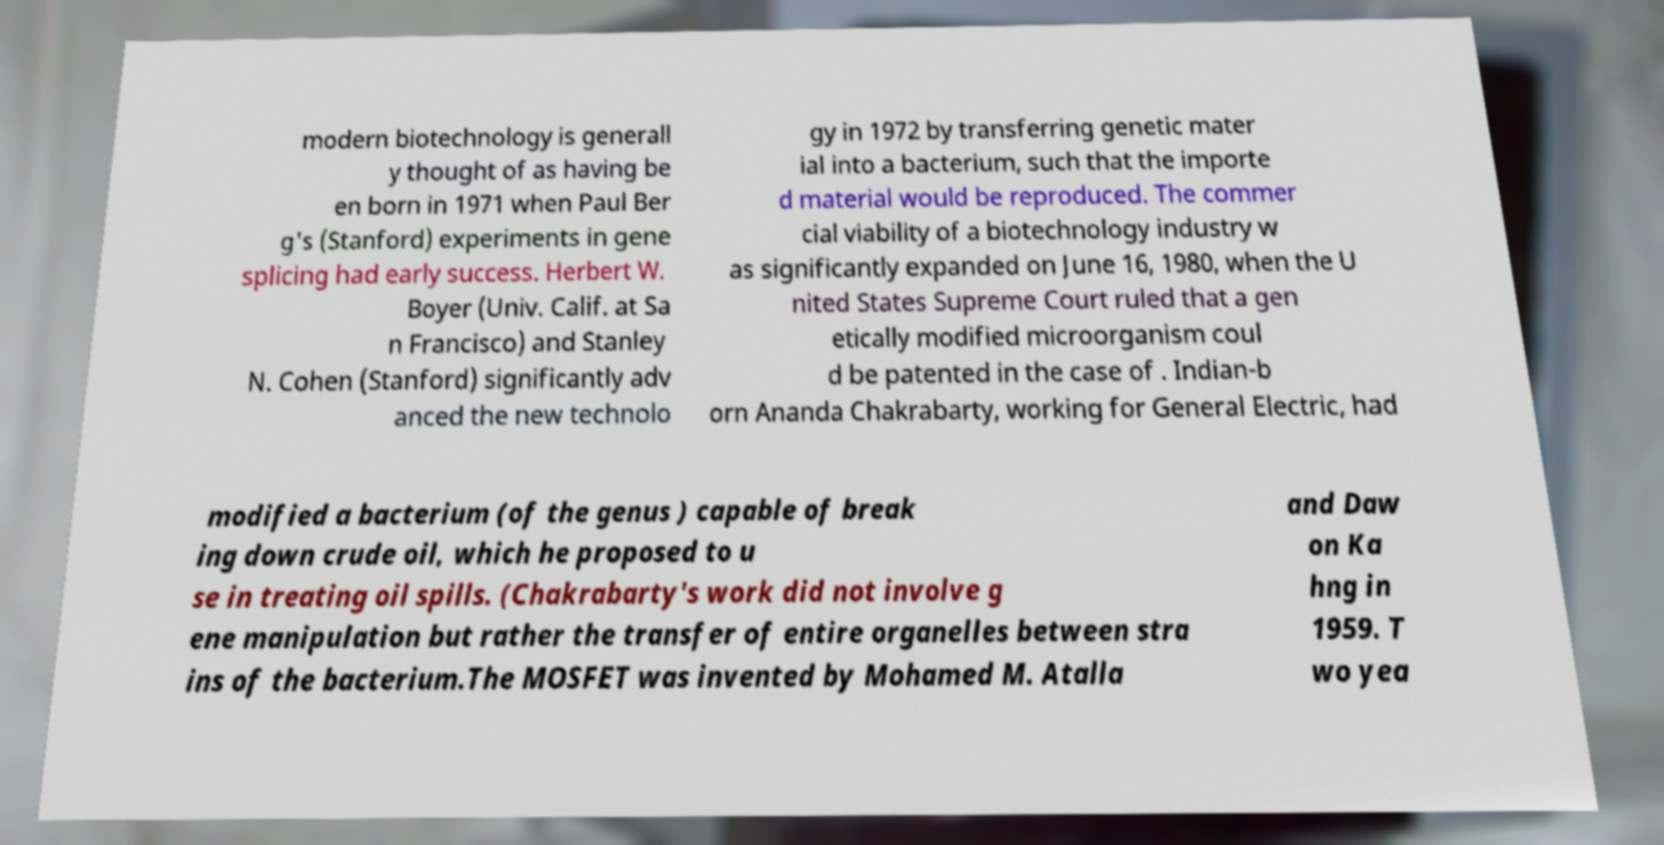Could you extract and type out the text from this image? modern biotechnology is generall y thought of as having be en born in 1971 when Paul Ber g's (Stanford) experiments in gene splicing had early success. Herbert W. Boyer (Univ. Calif. at Sa n Francisco) and Stanley N. Cohen (Stanford) significantly adv anced the new technolo gy in 1972 by transferring genetic mater ial into a bacterium, such that the importe d material would be reproduced. The commer cial viability of a biotechnology industry w as significantly expanded on June 16, 1980, when the U nited States Supreme Court ruled that a gen etically modified microorganism coul d be patented in the case of . Indian-b orn Ananda Chakrabarty, working for General Electric, had modified a bacterium (of the genus ) capable of break ing down crude oil, which he proposed to u se in treating oil spills. (Chakrabarty's work did not involve g ene manipulation but rather the transfer of entire organelles between stra ins of the bacterium.The MOSFET was invented by Mohamed M. Atalla and Daw on Ka hng in 1959. T wo yea 